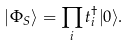Convert formula to latex. <formula><loc_0><loc_0><loc_500><loc_500>| \Phi _ { S } \rangle = \prod _ { i } t ^ { \dagger } _ { i } | 0 \rangle .</formula> 